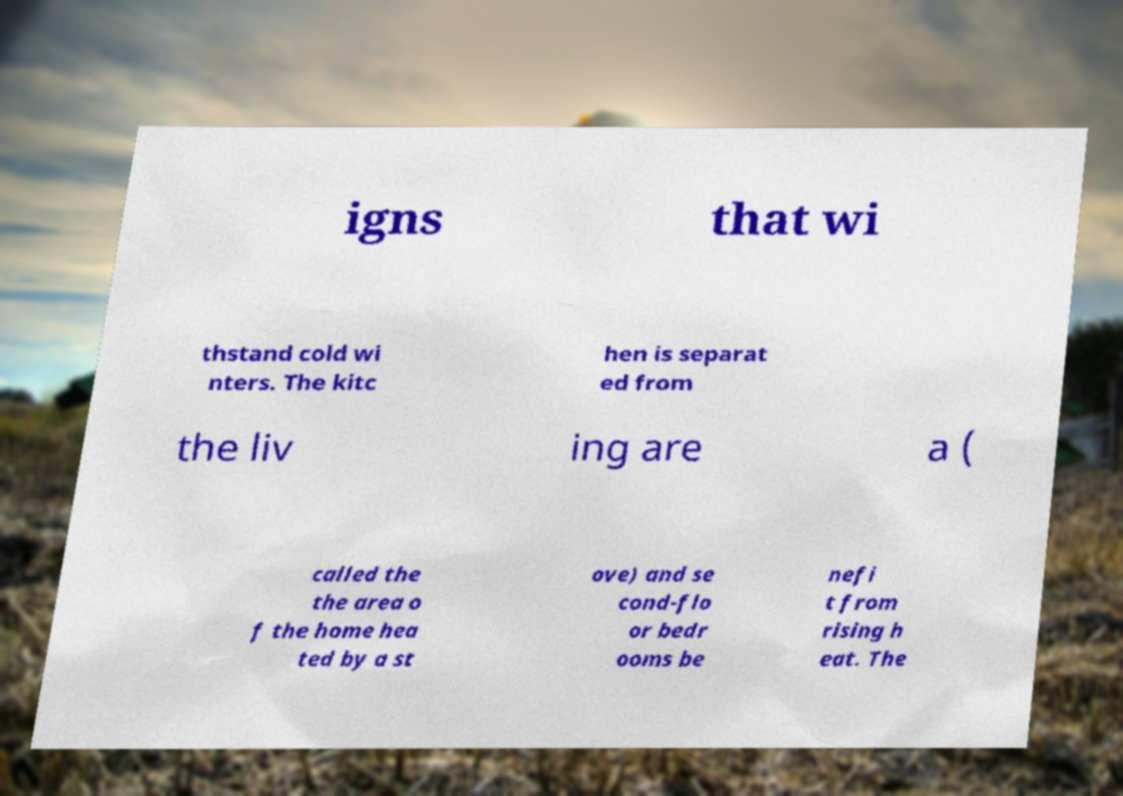What messages or text are displayed in this image? I need them in a readable, typed format. igns that wi thstand cold wi nters. The kitc hen is separat ed from the liv ing are a ( called the the area o f the home hea ted by a st ove) and se cond-flo or bedr ooms be nefi t from rising h eat. The 